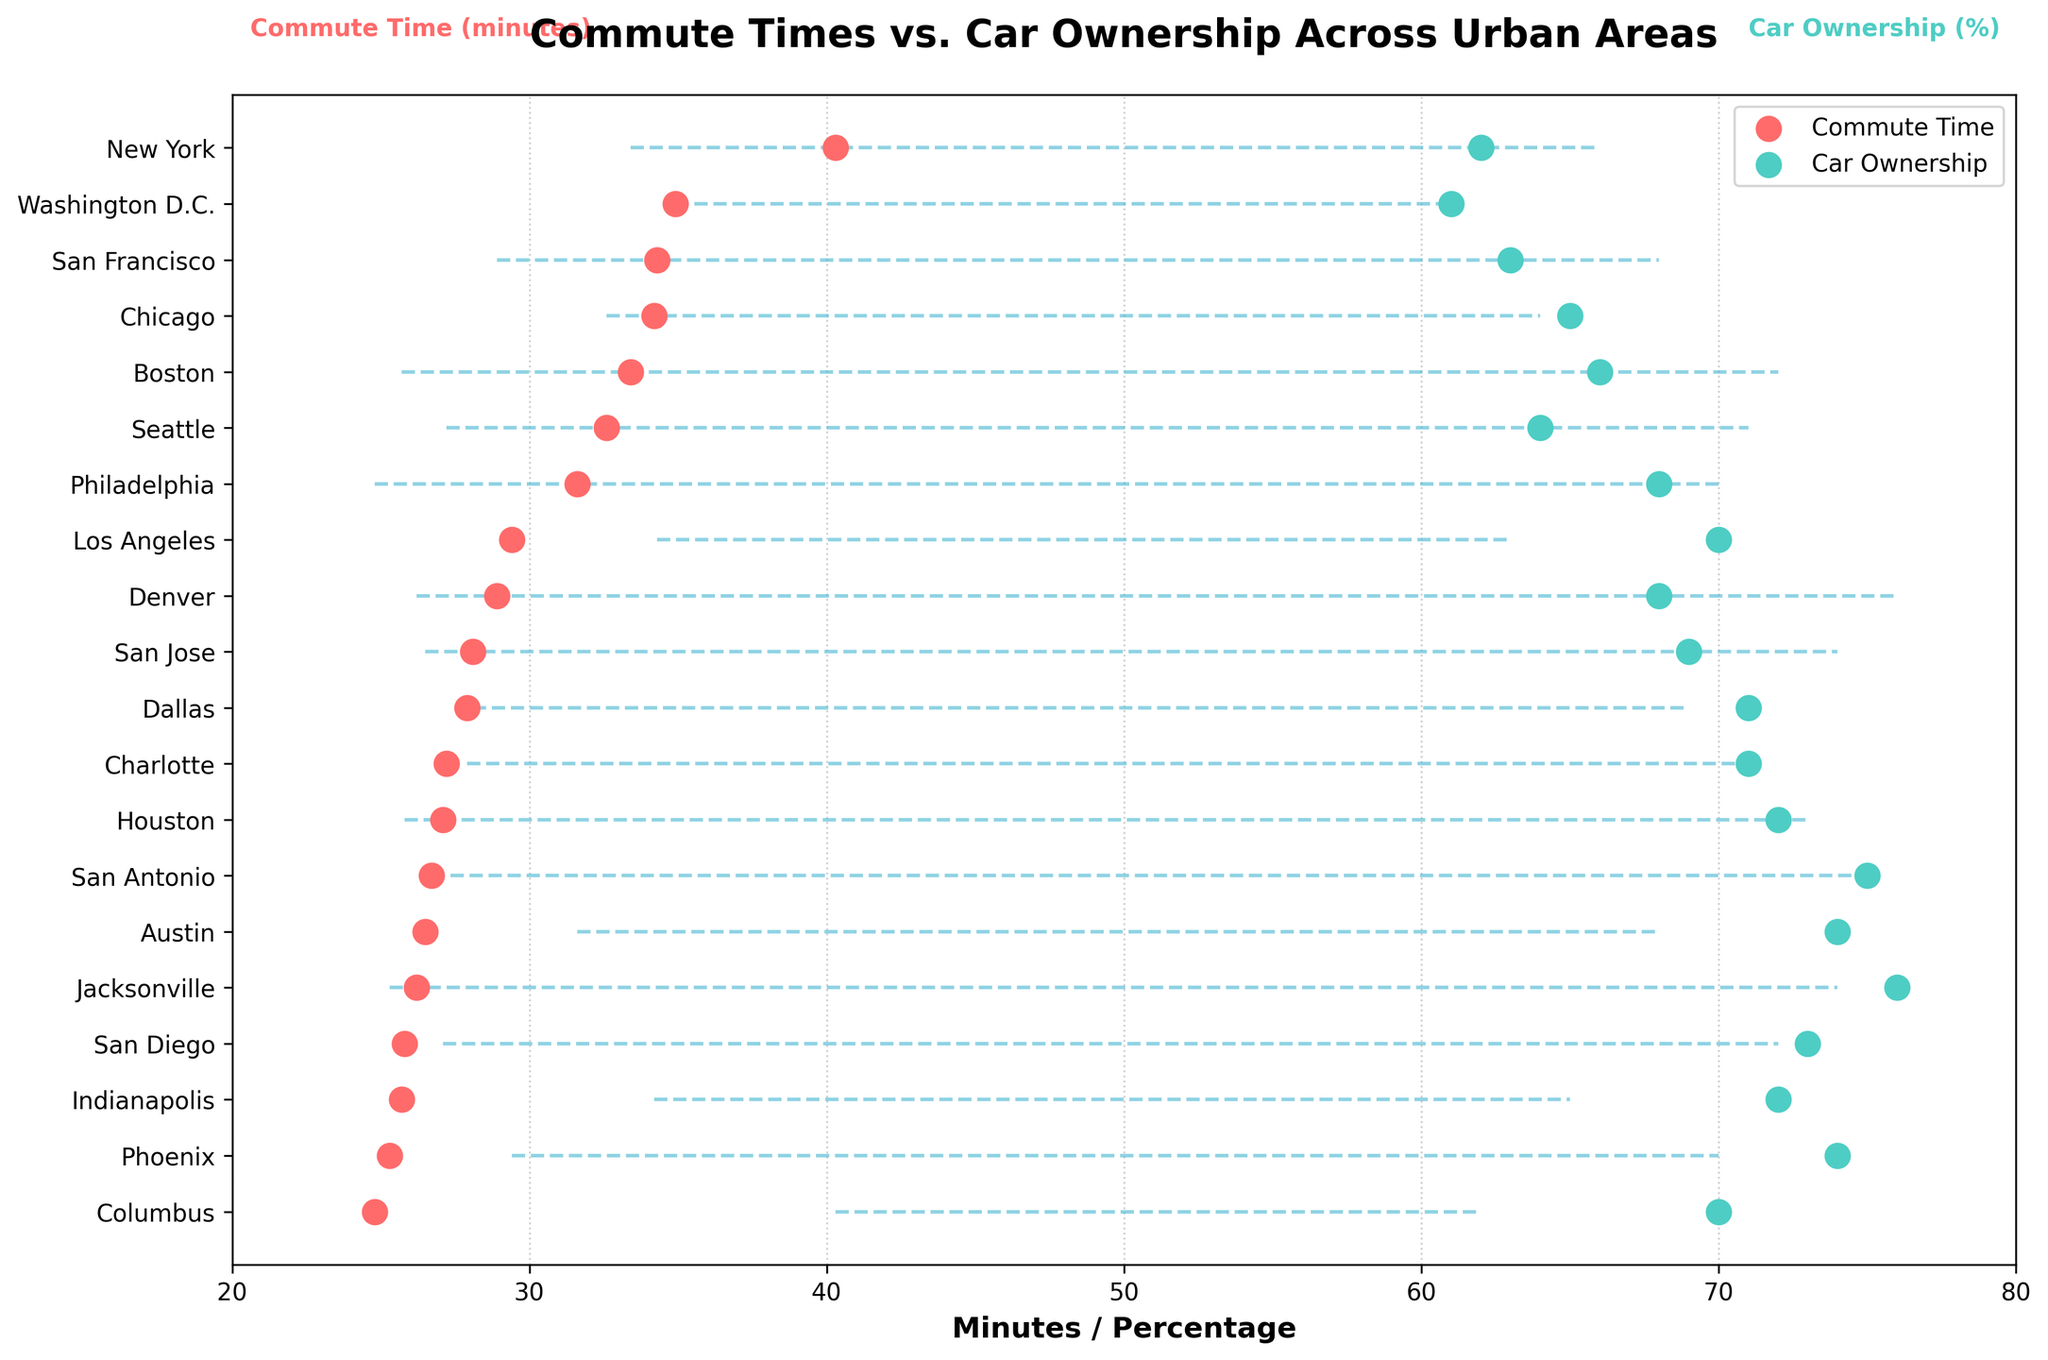How many cities are shown in the plot? Count the number of distinct cities listed along the y-axis.
Answer: 20 Which city has the highest car ownership percentage, and what is that percentage? Identify the dot aligned with the highest x-axis value in the car ownership color, noting its city label.
Answer: Jacksonville, 76% Which city has the shortest average commute time, and what is that time? Look for the dot with the lowest value on the x-axis in the commute time color, identifying the corresponding city.
Answer: Columbus, 24.8 minutes What is the average commute time across all cities? Sum all average commute times and divide by the number of cities: (40.3 + 29.4 + 34.2 + 27.1 + 25.3 + ... + 33.4) / 20.
Answer: 30.25 minutes Which city has a commute time closest to the average commute time? Calculate or use the average commute time found previously (30.25 minutes). Find the city dot closest to this x-axis value for commute times.
Answer: Philadelphia, 31.6 minutes Are there any cities where the car ownership and the average commute time are nearly the same? Look for any instances where the dots for a single city have x-axis values that are very close.
Answer: No, there are no cities where the values nearly match Which city has the lowest car ownership percentage, and what is it? Identify the dot aligned with the lowest value on the x-axis in the car ownership color, noting its city label.
Answer: Washington D.C., 61% Is there a general trend between commute times and car ownership percentages in the plot? Compare commute times with car ownership for multiple cities to understand if they tend to rise or fall together or show another pattern.
Answer: No clear trend, varied relationship Do cities with higher car ownership percentages generally have lower average commute times? Compare several cities' commute times and car ownership percentages to determine if higher car ownership correlates with shorter commutes.
Answer: Generally, yes 